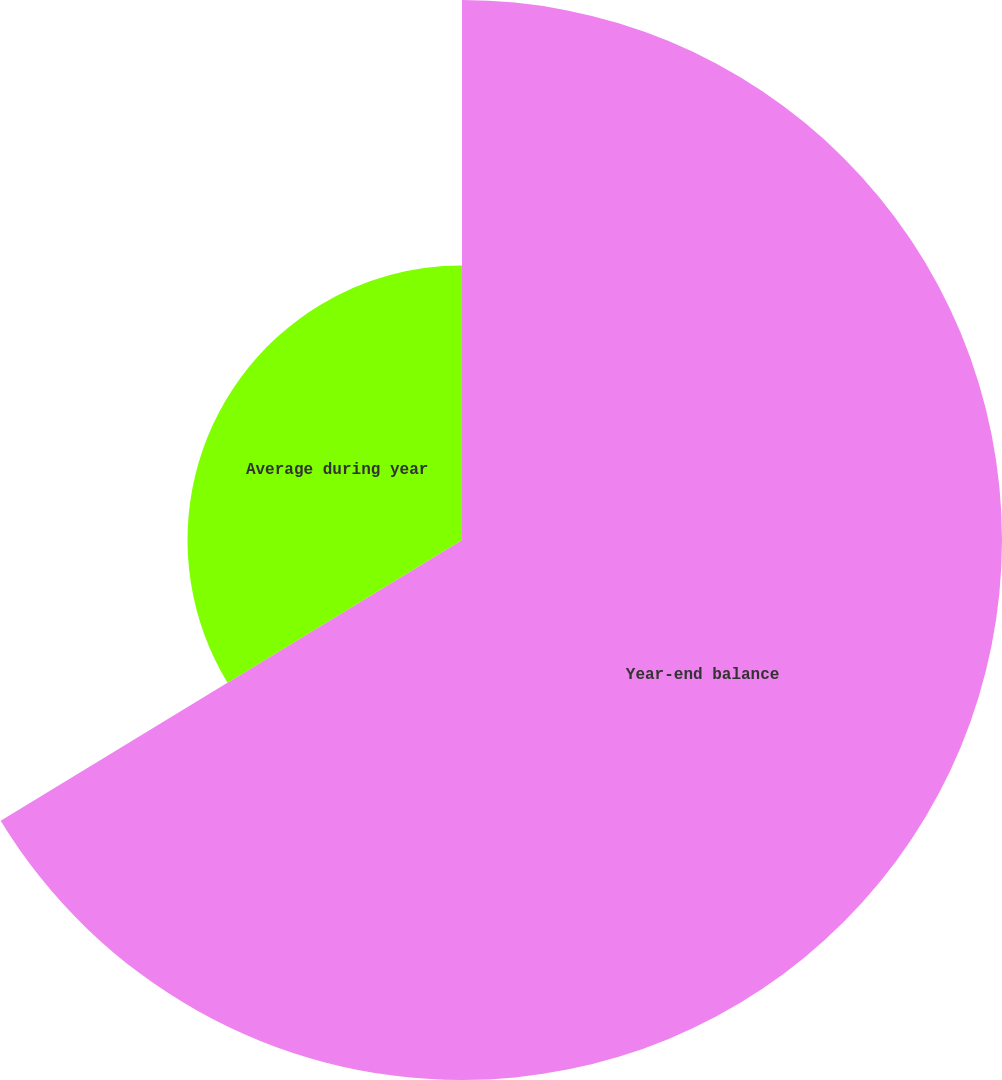Convert chart. <chart><loc_0><loc_0><loc_500><loc_500><pie_chart><fcel>Year-end balance<fcel>Average during year<nl><fcel>66.3%<fcel>33.7%<nl></chart> 